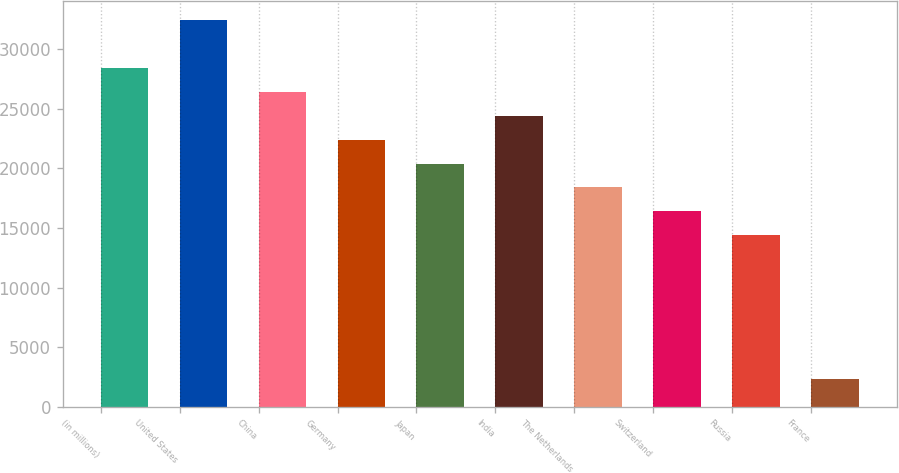Convert chart to OTSL. <chart><loc_0><loc_0><loc_500><loc_500><bar_chart><fcel>(in millions)<fcel>United States<fcel>China<fcel>Germany<fcel>Japan<fcel>India<fcel>The Netherlands<fcel>Switzerland<fcel>Russia<fcel>France<nl><fcel>28434.6<fcel>32449.4<fcel>26427.2<fcel>22412.4<fcel>20405<fcel>24419.8<fcel>18397.6<fcel>16390.2<fcel>14382.8<fcel>2338.4<nl></chart> 